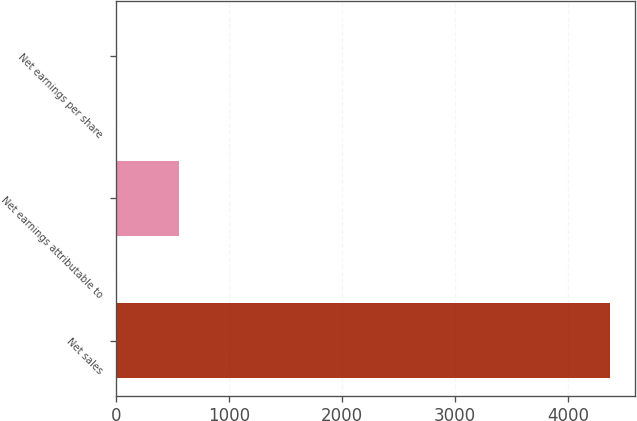<chart> <loc_0><loc_0><loc_500><loc_500><bar_chart><fcel>Net sales<fcel>Net earnings attributable to<fcel>Net earnings per share<nl><fcel>4373.9<fcel>553.9<fcel>7.71<nl></chart> 